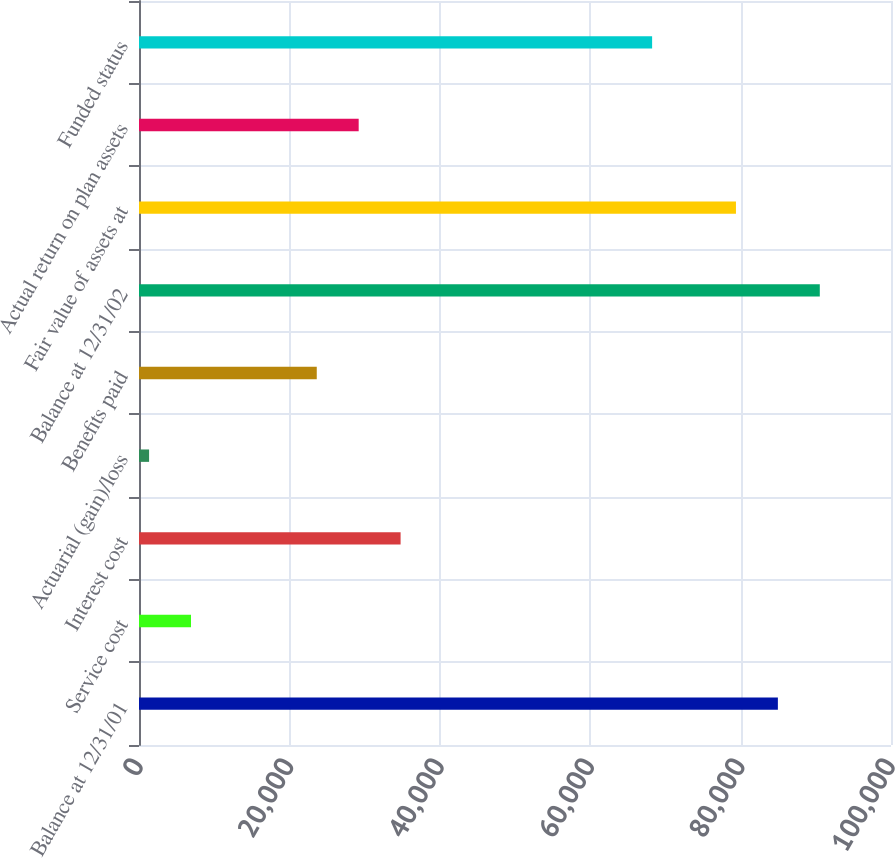Convert chart to OTSL. <chart><loc_0><loc_0><loc_500><loc_500><bar_chart><fcel>Balance at 12/31/01<fcel>Service cost<fcel>Interest cost<fcel>Actuarial (gain)/loss<fcel>Benefits paid<fcel>Balance at 12/31/02<fcel>Fair value of assets at<fcel>Actual return on plan assets<fcel>Funded status<nl><fcel>84957<fcel>6915.4<fcel>34787.4<fcel>1341<fcel>23638.6<fcel>90531.4<fcel>79382.6<fcel>29213<fcel>68233.8<nl></chart> 